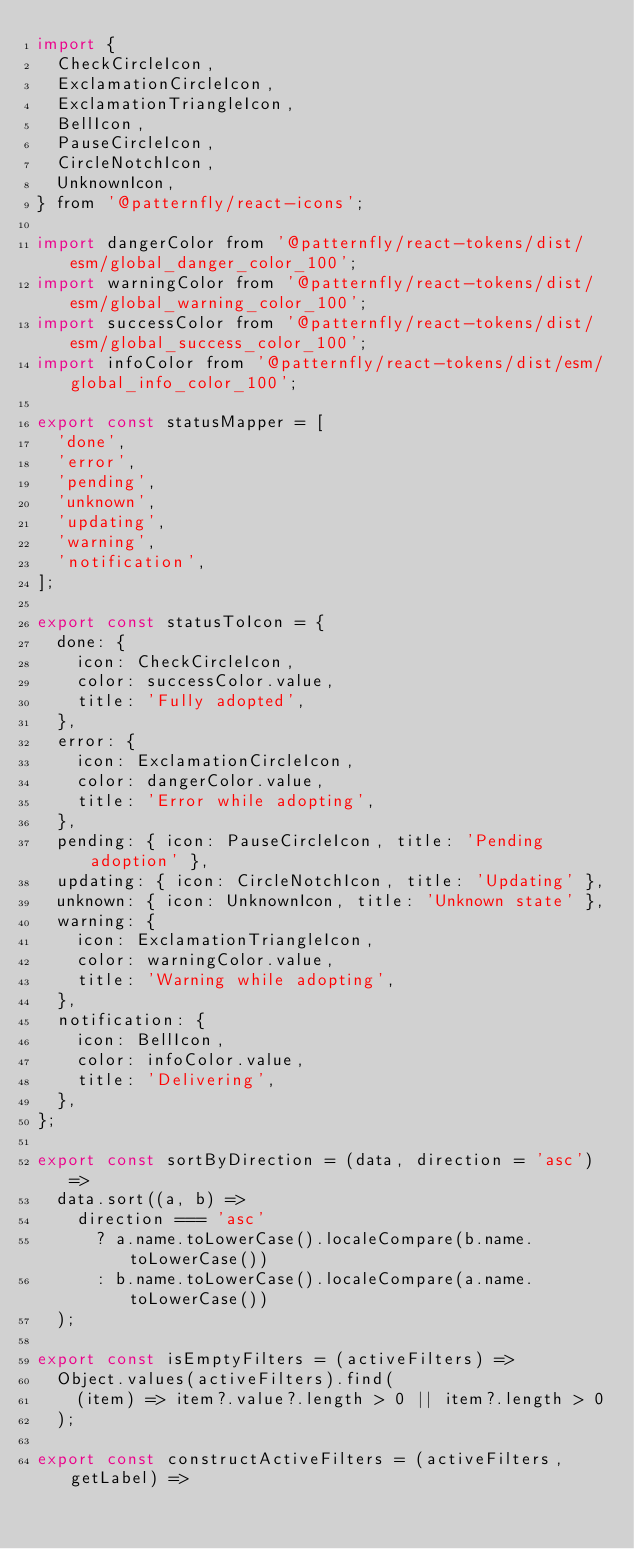<code> <loc_0><loc_0><loc_500><loc_500><_JavaScript_>import {
  CheckCircleIcon,
  ExclamationCircleIcon,
  ExclamationTriangleIcon,
  BellIcon,
  PauseCircleIcon,
  CircleNotchIcon,
  UnknownIcon,
} from '@patternfly/react-icons';

import dangerColor from '@patternfly/react-tokens/dist/esm/global_danger_color_100';
import warningColor from '@patternfly/react-tokens/dist/esm/global_warning_color_100';
import successColor from '@patternfly/react-tokens/dist/esm/global_success_color_100';
import infoColor from '@patternfly/react-tokens/dist/esm/global_info_color_100';

export const statusMapper = [
  'done',
  'error',
  'pending',
  'unknown',
  'updating',
  'warning',
  'notification',
];

export const statusToIcon = {
  done: {
    icon: CheckCircleIcon,
    color: successColor.value,
    title: 'Fully adopted',
  },
  error: {
    icon: ExclamationCircleIcon,
    color: dangerColor.value,
    title: 'Error while adopting',
  },
  pending: { icon: PauseCircleIcon, title: 'Pending adoption' },
  updating: { icon: CircleNotchIcon, title: 'Updating' },
  unknown: { icon: UnknownIcon, title: 'Unknown state' },
  warning: {
    icon: ExclamationTriangleIcon,
    color: warningColor.value,
    title: 'Warning while adopting',
  },
  notification: {
    icon: BellIcon,
    color: infoColor.value,
    title: 'Delivering',
  },
};

export const sortByDirection = (data, direction = 'asc') =>
  data.sort((a, b) =>
    direction === 'asc'
      ? a.name.toLowerCase().localeCompare(b.name.toLowerCase())
      : b.name.toLowerCase().localeCompare(a.name.toLowerCase())
  );

export const isEmptyFilters = (activeFilters) =>
  Object.values(activeFilters).find(
    (item) => item?.value?.length > 0 || item?.length > 0
  );

export const constructActiveFilters = (activeFilters, getLabel) =></code> 